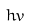Convert formula to latex. <formula><loc_0><loc_0><loc_500><loc_500>h v</formula> 